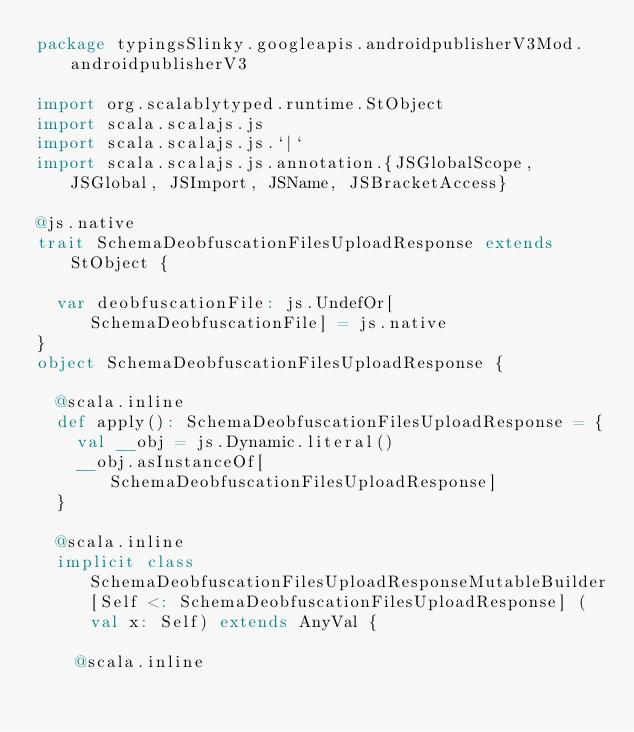<code> <loc_0><loc_0><loc_500><loc_500><_Scala_>package typingsSlinky.googleapis.androidpublisherV3Mod.androidpublisherV3

import org.scalablytyped.runtime.StObject
import scala.scalajs.js
import scala.scalajs.js.`|`
import scala.scalajs.js.annotation.{JSGlobalScope, JSGlobal, JSImport, JSName, JSBracketAccess}

@js.native
trait SchemaDeobfuscationFilesUploadResponse extends StObject {
  
  var deobfuscationFile: js.UndefOr[SchemaDeobfuscationFile] = js.native
}
object SchemaDeobfuscationFilesUploadResponse {
  
  @scala.inline
  def apply(): SchemaDeobfuscationFilesUploadResponse = {
    val __obj = js.Dynamic.literal()
    __obj.asInstanceOf[SchemaDeobfuscationFilesUploadResponse]
  }
  
  @scala.inline
  implicit class SchemaDeobfuscationFilesUploadResponseMutableBuilder[Self <: SchemaDeobfuscationFilesUploadResponse] (val x: Self) extends AnyVal {
    
    @scala.inline</code> 